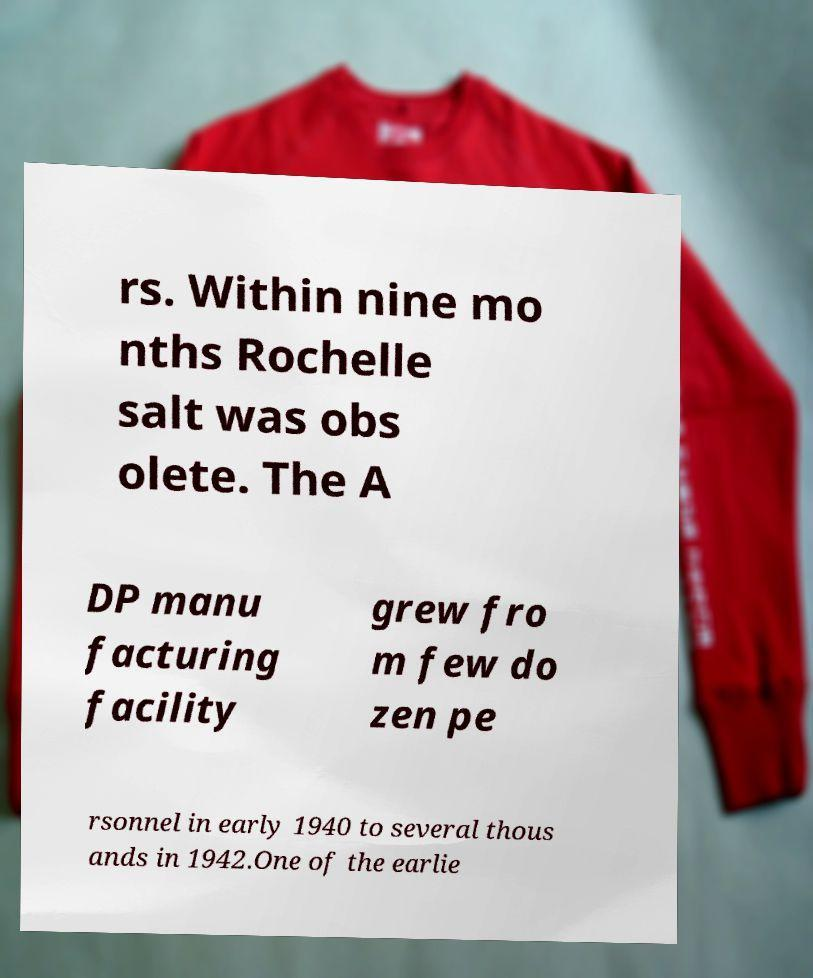Please identify and transcribe the text found in this image. rs. Within nine mo nths Rochelle salt was obs olete. The A DP manu facturing facility grew fro m few do zen pe rsonnel in early 1940 to several thous ands in 1942.One of the earlie 